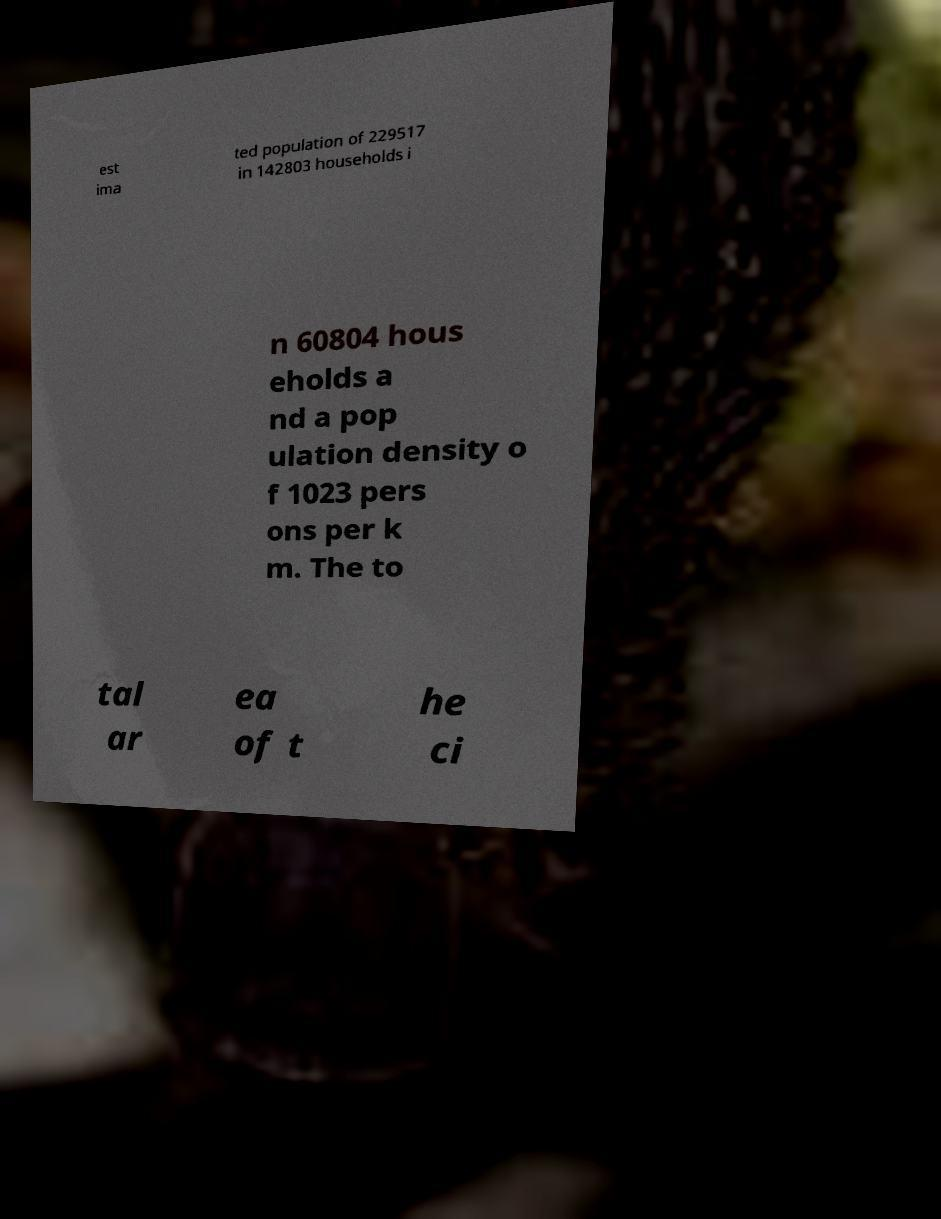For documentation purposes, I need the text within this image transcribed. Could you provide that? est ima ted population of 229517 in 142803 households i n 60804 hous eholds a nd a pop ulation density o f 1023 pers ons per k m. The to tal ar ea of t he ci 